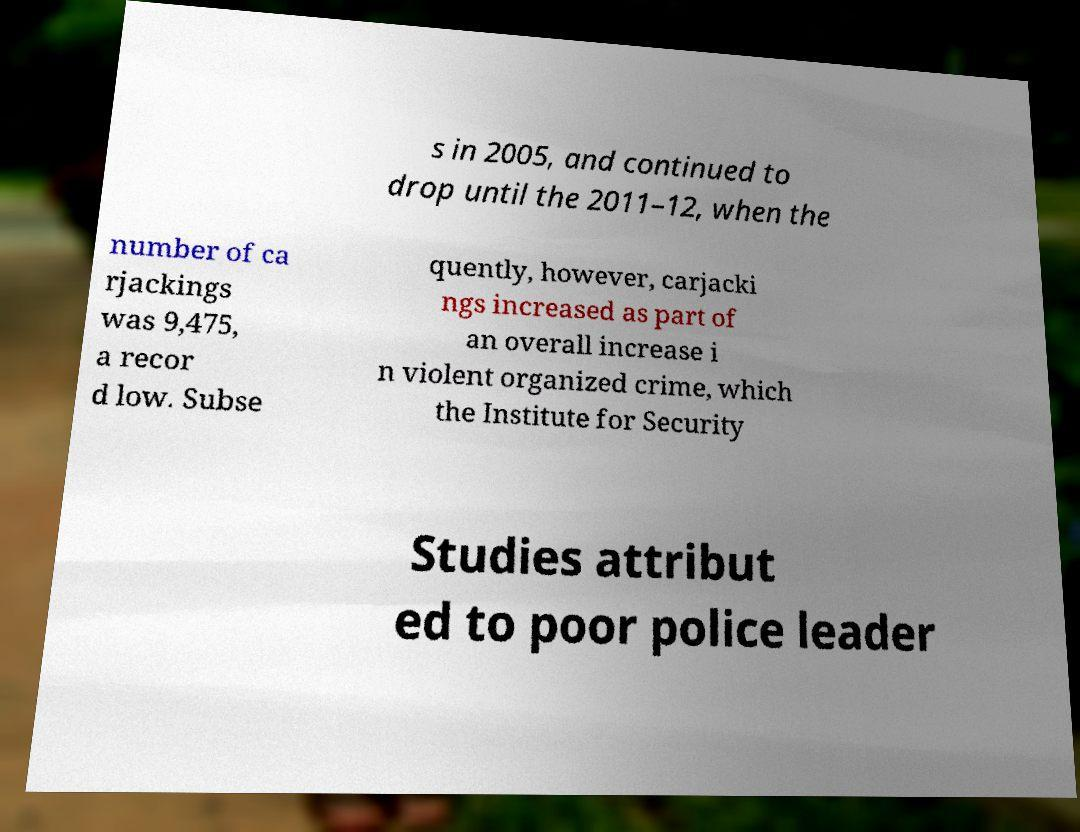What messages or text are displayed in this image? I need them in a readable, typed format. s in 2005, and continued to drop until the 2011–12, when the number of ca rjackings was 9,475, a recor d low. Subse quently, however, carjacki ngs increased as part of an overall increase i n violent organized crime, which the Institute for Security Studies attribut ed to poor police leader 